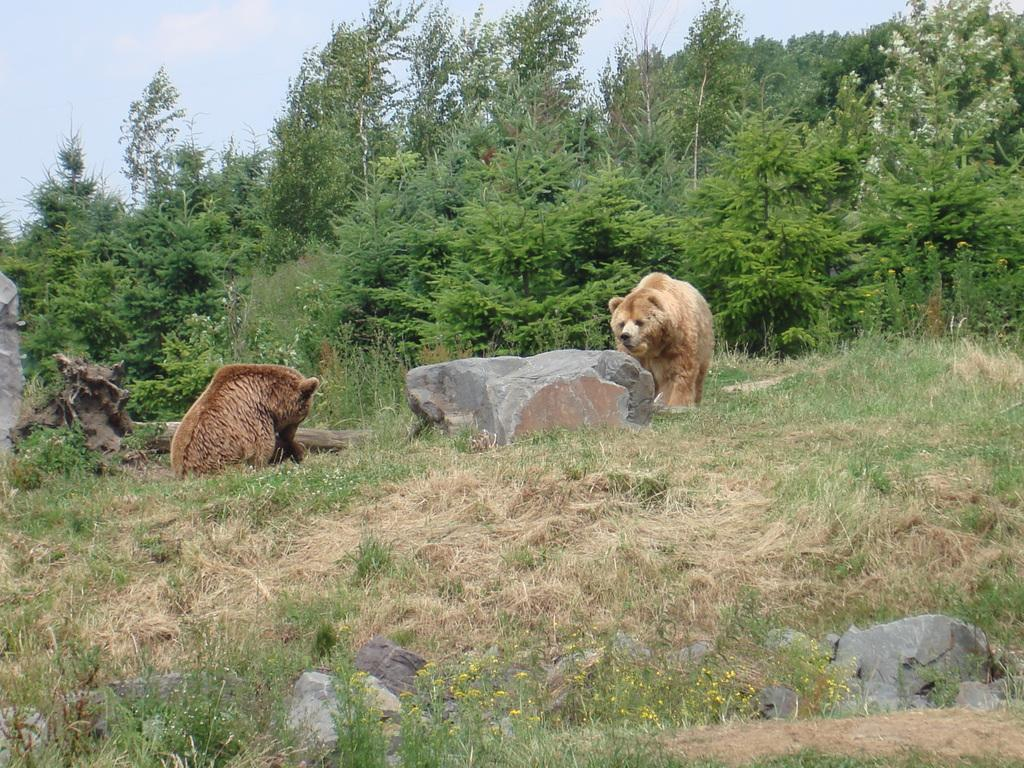What animals are in the foreground of the image? There are two bears in the foreground of the image. What is the bears' location in relation to the grass? The bears are on the grass. What can be seen in the background of the image? Trees, rocks, plants, grass, and the sky are visible in the background of the image. What type of flame can be seen coming from the bears' mouths in the image? There is no flame present in the image; the bears are not depicted as breathing fire. 